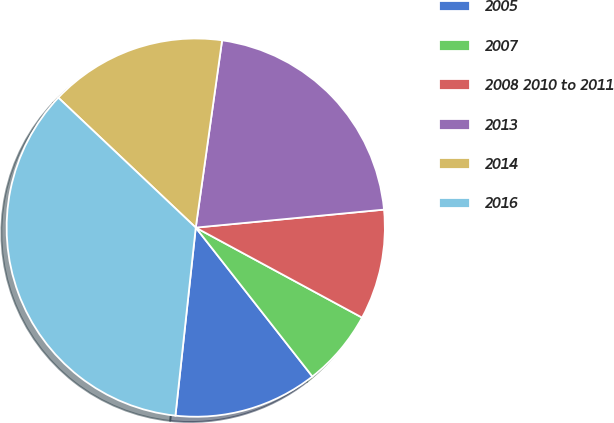Convert chart to OTSL. <chart><loc_0><loc_0><loc_500><loc_500><pie_chart><fcel>2005<fcel>2007<fcel>2008 2010 to 2011<fcel>2013<fcel>2014<fcel>2016<nl><fcel>12.29%<fcel>6.53%<fcel>9.41%<fcel>21.26%<fcel>15.17%<fcel>35.34%<nl></chart> 